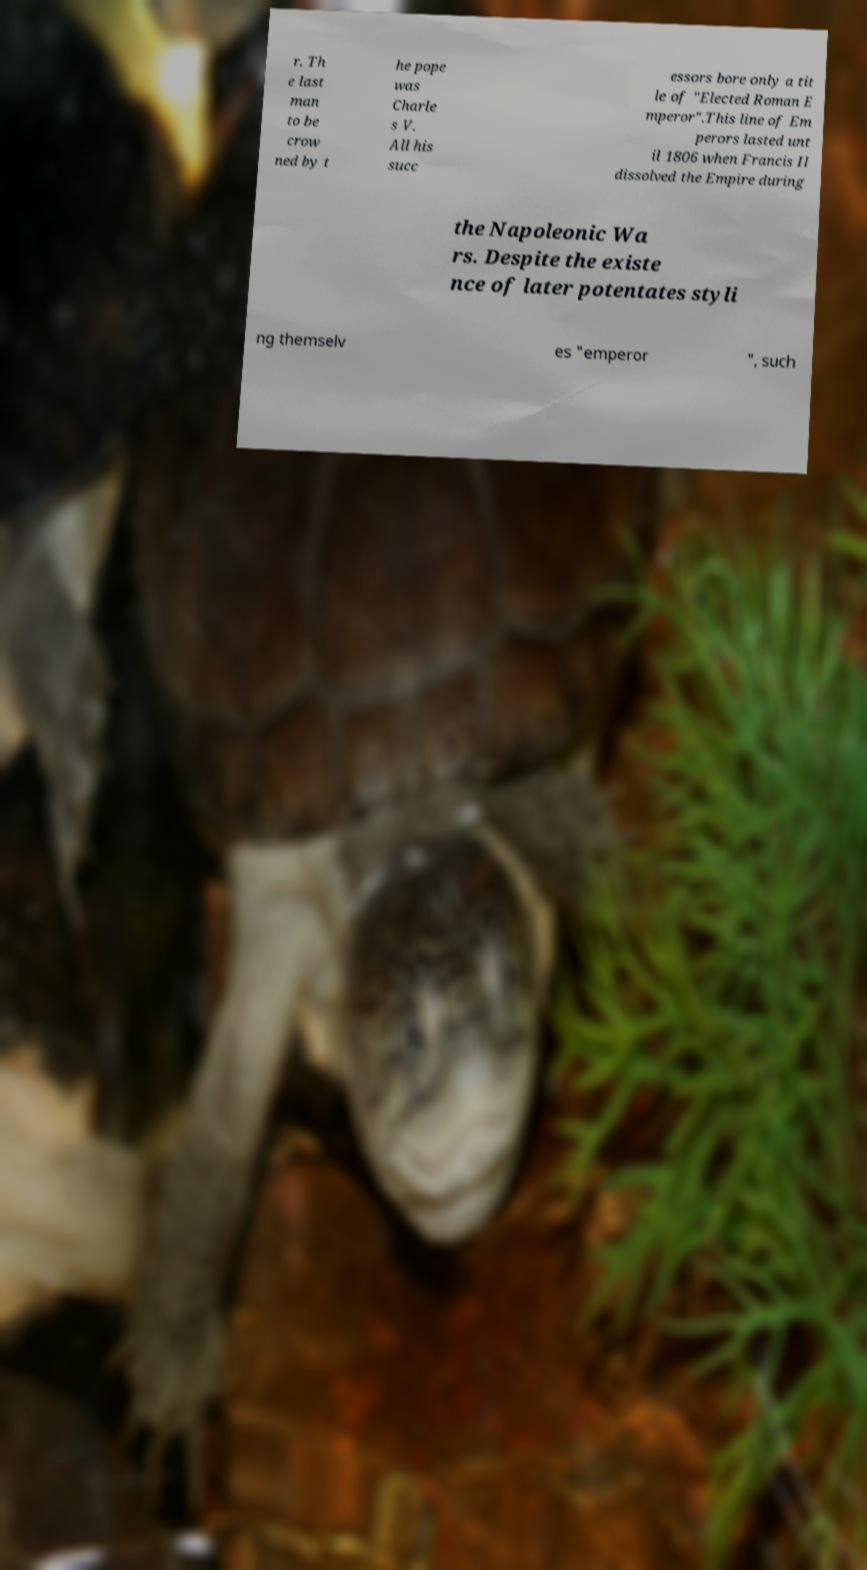For documentation purposes, I need the text within this image transcribed. Could you provide that? r. Th e last man to be crow ned by t he pope was Charle s V. All his succ essors bore only a tit le of "Elected Roman E mperor".This line of Em perors lasted unt il 1806 when Francis II dissolved the Empire during the Napoleonic Wa rs. Despite the existe nce of later potentates styli ng themselv es "emperor ", such 